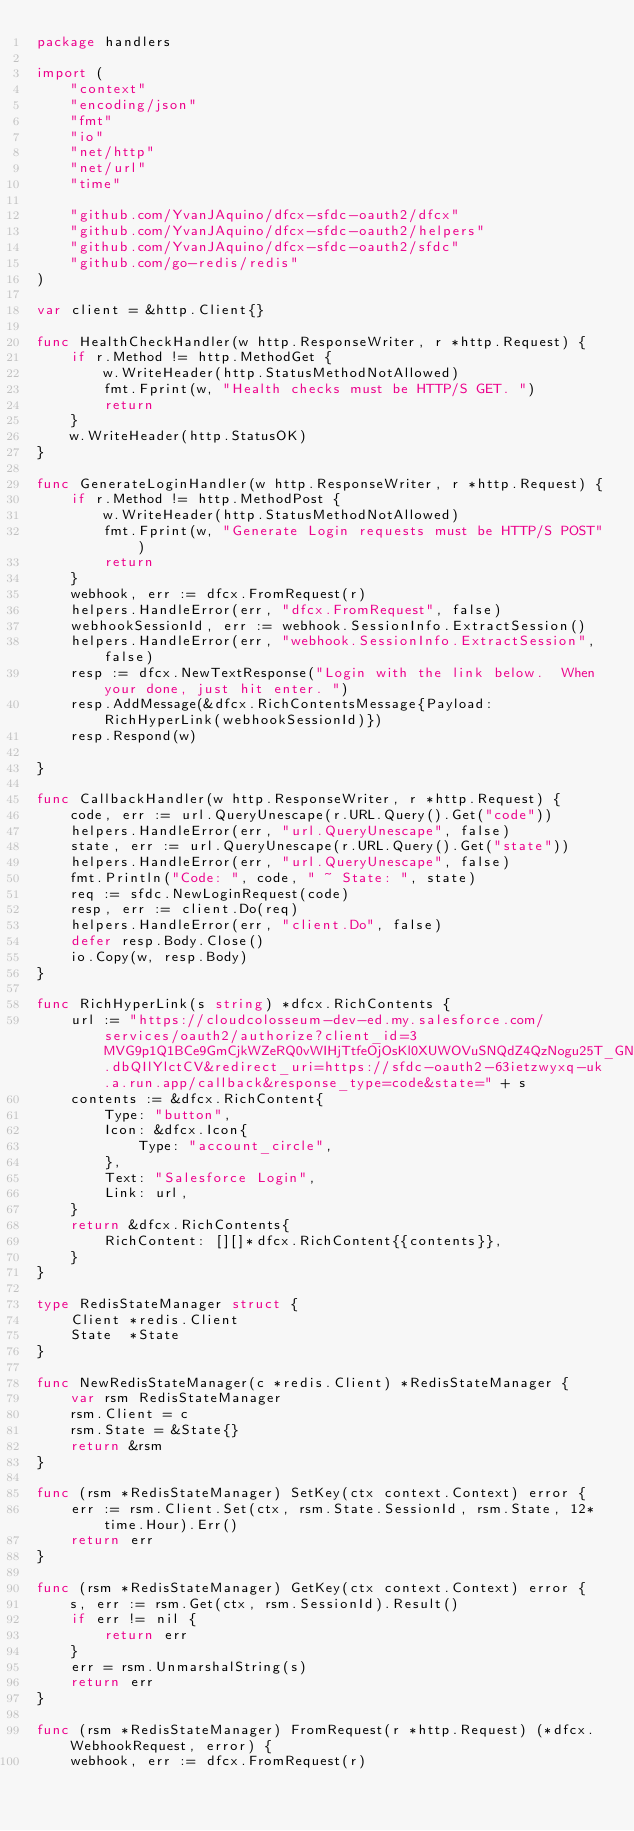<code> <loc_0><loc_0><loc_500><loc_500><_Go_>package handlers

import (
	"context"
	"encoding/json"
	"fmt"
	"io"
	"net/http"
	"net/url"
	"time"

	"github.com/YvanJAquino/dfcx-sfdc-oauth2/dfcx"
	"github.com/YvanJAquino/dfcx-sfdc-oauth2/helpers"
	"github.com/YvanJAquino/dfcx-sfdc-oauth2/sfdc"
	"github.com/go-redis/redis"
)

var client = &http.Client{}

func HealthCheckHandler(w http.ResponseWriter, r *http.Request) {
	if r.Method != http.MethodGet {
		w.WriteHeader(http.StatusMethodNotAllowed)
		fmt.Fprint(w, "Health checks must be HTTP/S GET. ")
		return
	}
	w.WriteHeader(http.StatusOK)
}

func GenerateLoginHandler(w http.ResponseWriter, r *http.Request) {
	if r.Method != http.MethodPost {
		w.WriteHeader(http.StatusMethodNotAllowed)
		fmt.Fprint(w, "Generate Login requests must be HTTP/S POST")
		return
	}
	webhook, err := dfcx.FromRequest(r)
	helpers.HandleError(err, "dfcx.FromRequest", false)
	webhookSessionId, err := webhook.SessionInfo.ExtractSession()
	helpers.HandleError(err, "webhook.SessionInfo.ExtractSession", false)
	resp := dfcx.NewTextResponse("Login with the link below.  When your done, just hit enter. ")
	resp.AddMessage(&dfcx.RichContentsMessage{Payload: RichHyperLink(webhookSessionId)})
	resp.Respond(w)

}

func CallbackHandler(w http.ResponseWriter, r *http.Request) {
	code, err := url.QueryUnescape(r.URL.Query().Get("code"))
	helpers.HandleError(err, "url.QueryUnescape", false)
	state, err := url.QueryUnescape(r.URL.Query().Get("state"))
	helpers.HandleError(err, "url.QueryUnescape", false)
	fmt.Println("Code: ", code, " ~ State: ", state)
	req := sfdc.NewLoginRequest(code)
	resp, err := client.Do(req)
	helpers.HandleError(err, "client.Do", false)
	defer resp.Body.Close()
	io.Copy(w, resp.Body)
}

func RichHyperLink(s string) *dfcx.RichContents {
	url := "https://cloudcolosseum-dev-ed.my.salesforce.com/services/oauth2/authorize?client_id=3MVG9p1Q1BCe9GmCjkWZeRQ0vWIHjTtfeOjOsKl0XUWOVuSNQdZ4QzNogu25T_GNO3G3BmaNz.dbQIlYlctCV&redirect_uri=https://sfdc-oauth2-63ietzwyxq-uk.a.run.app/callback&response_type=code&state=" + s
	contents := &dfcx.RichContent{
		Type: "button",
		Icon: &dfcx.Icon{
			Type: "account_circle",
		},
		Text: "Salesforce Login",
		Link: url,
	}
	return &dfcx.RichContents{
		RichContent: [][]*dfcx.RichContent{{contents}},
	}
}

type RedisStateManager struct {
	Client *redis.Client
	State  *State
}

func NewRedisStateManager(c *redis.Client) *RedisStateManager {
	var rsm RedisStateManager
	rsm.Client = c
	rsm.State = &State{}
	return &rsm
}

func (rsm *RedisStateManager) SetKey(ctx context.Context) error {
	err := rsm.Client.Set(ctx, rsm.State.SessionId, rsm.State, 12*time.Hour).Err()
	return err
}

func (rsm *RedisStateManager) GetKey(ctx context.Context) error {
	s, err := rsm.Get(ctx, rsm.SessionId).Result()
	if err != nil {
		return err
	}
	err = rsm.UnmarshalString(s)
	return err
}

func (rsm *RedisStateManager) FromRequest(r *http.Request) (*dfcx.WebhookRequest, error) {
	webhook, err := dfcx.FromRequest(r)</code> 